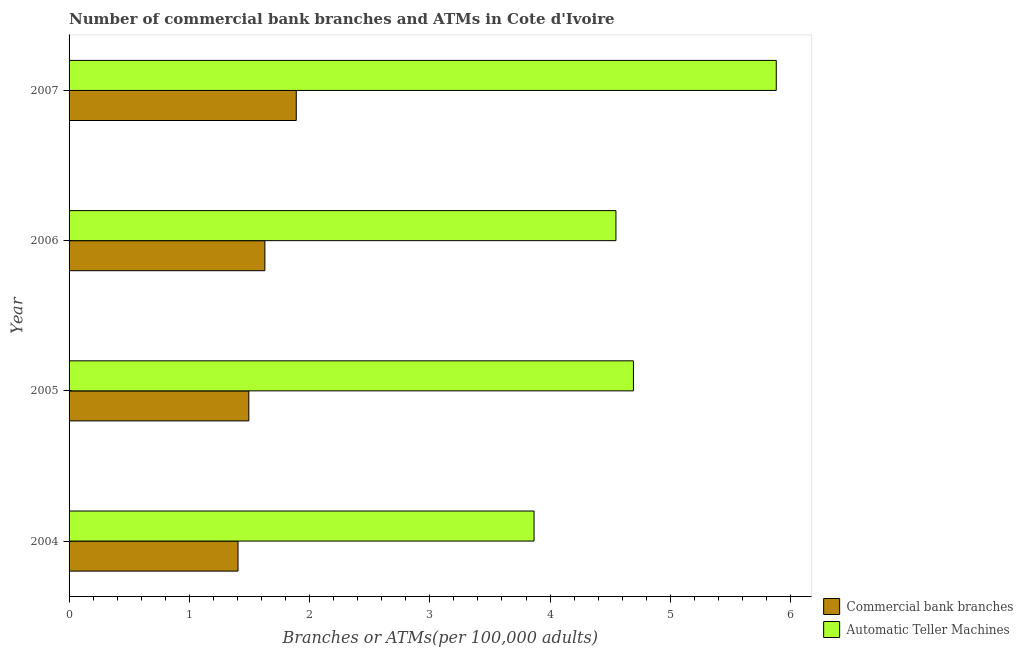How many different coloured bars are there?
Your response must be concise. 2. How many groups of bars are there?
Provide a succinct answer. 4. Are the number of bars per tick equal to the number of legend labels?
Your answer should be compact. Yes. How many bars are there on the 3rd tick from the bottom?
Your response must be concise. 2. What is the label of the 4th group of bars from the top?
Make the answer very short. 2004. In how many cases, is the number of bars for a given year not equal to the number of legend labels?
Offer a very short reply. 0. What is the number of atms in 2005?
Offer a terse response. 4.69. Across all years, what is the maximum number of commercal bank branches?
Your response must be concise. 1.89. Across all years, what is the minimum number of commercal bank branches?
Offer a terse response. 1.41. In which year was the number of commercal bank branches maximum?
Your answer should be very brief. 2007. What is the total number of atms in the graph?
Provide a succinct answer. 18.99. What is the difference between the number of atms in 2004 and that in 2006?
Give a very brief answer. -0.68. What is the difference between the number of commercal bank branches in 2005 and the number of atms in 2007?
Provide a succinct answer. -4.39. What is the average number of atms per year?
Provide a short and direct response. 4.75. In the year 2007, what is the difference between the number of commercal bank branches and number of atms?
Provide a short and direct response. -3.99. What is the ratio of the number of atms in 2005 to that in 2006?
Keep it short and to the point. 1.03. Is the number of commercal bank branches in 2006 less than that in 2007?
Ensure brevity in your answer.  Yes. Is the difference between the number of atms in 2004 and 2006 greater than the difference between the number of commercal bank branches in 2004 and 2006?
Provide a succinct answer. No. What is the difference between the highest and the second highest number of commercal bank branches?
Your answer should be compact. 0.26. What is the difference between the highest and the lowest number of commercal bank branches?
Make the answer very short. 0.48. In how many years, is the number of atms greater than the average number of atms taken over all years?
Make the answer very short. 1. What does the 1st bar from the top in 2007 represents?
Offer a very short reply. Automatic Teller Machines. What does the 2nd bar from the bottom in 2004 represents?
Provide a short and direct response. Automatic Teller Machines. Are all the bars in the graph horizontal?
Offer a very short reply. Yes. How many years are there in the graph?
Provide a succinct answer. 4. What is the difference between two consecutive major ticks on the X-axis?
Your response must be concise. 1. Are the values on the major ticks of X-axis written in scientific E-notation?
Provide a succinct answer. No. Does the graph contain grids?
Provide a succinct answer. No. Where does the legend appear in the graph?
Keep it short and to the point. Bottom right. What is the title of the graph?
Offer a very short reply. Number of commercial bank branches and ATMs in Cote d'Ivoire. Does "Constant 2005 US$" appear as one of the legend labels in the graph?
Keep it short and to the point. No. What is the label or title of the X-axis?
Give a very brief answer. Branches or ATMs(per 100,0 adults). What is the label or title of the Y-axis?
Ensure brevity in your answer.  Year. What is the Branches or ATMs(per 100,000 adults) in Commercial bank branches in 2004?
Your answer should be very brief. 1.41. What is the Branches or ATMs(per 100,000 adults) in Automatic Teller Machines in 2004?
Give a very brief answer. 3.87. What is the Branches or ATMs(per 100,000 adults) of Commercial bank branches in 2005?
Provide a short and direct response. 1.5. What is the Branches or ATMs(per 100,000 adults) in Automatic Teller Machines in 2005?
Ensure brevity in your answer.  4.69. What is the Branches or ATMs(per 100,000 adults) of Commercial bank branches in 2006?
Make the answer very short. 1.63. What is the Branches or ATMs(per 100,000 adults) in Automatic Teller Machines in 2006?
Make the answer very short. 4.55. What is the Branches or ATMs(per 100,000 adults) of Commercial bank branches in 2007?
Ensure brevity in your answer.  1.89. What is the Branches or ATMs(per 100,000 adults) of Automatic Teller Machines in 2007?
Make the answer very short. 5.88. Across all years, what is the maximum Branches or ATMs(per 100,000 adults) of Commercial bank branches?
Give a very brief answer. 1.89. Across all years, what is the maximum Branches or ATMs(per 100,000 adults) of Automatic Teller Machines?
Keep it short and to the point. 5.88. Across all years, what is the minimum Branches or ATMs(per 100,000 adults) in Commercial bank branches?
Your response must be concise. 1.41. Across all years, what is the minimum Branches or ATMs(per 100,000 adults) of Automatic Teller Machines?
Offer a terse response. 3.87. What is the total Branches or ATMs(per 100,000 adults) of Commercial bank branches in the graph?
Your answer should be very brief. 6.42. What is the total Branches or ATMs(per 100,000 adults) in Automatic Teller Machines in the graph?
Provide a succinct answer. 18.99. What is the difference between the Branches or ATMs(per 100,000 adults) of Commercial bank branches in 2004 and that in 2005?
Keep it short and to the point. -0.09. What is the difference between the Branches or ATMs(per 100,000 adults) of Automatic Teller Machines in 2004 and that in 2005?
Offer a very short reply. -0.83. What is the difference between the Branches or ATMs(per 100,000 adults) of Commercial bank branches in 2004 and that in 2006?
Your response must be concise. -0.22. What is the difference between the Branches or ATMs(per 100,000 adults) in Automatic Teller Machines in 2004 and that in 2006?
Give a very brief answer. -0.68. What is the difference between the Branches or ATMs(per 100,000 adults) of Commercial bank branches in 2004 and that in 2007?
Your answer should be very brief. -0.48. What is the difference between the Branches or ATMs(per 100,000 adults) in Automatic Teller Machines in 2004 and that in 2007?
Give a very brief answer. -2.01. What is the difference between the Branches or ATMs(per 100,000 adults) in Commercial bank branches in 2005 and that in 2006?
Make the answer very short. -0.13. What is the difference between the Branches or ATMs(per 100,000 adults) in Automatic Teller Machines in 2005 and that in 2006?
Offer a very short reply. 0.15. What is the difference between the Branches or ATMs(per 100,000 adults) in Commercial bank branches in 2005 and that in 2007?
Ensure brevity in your answer.  -0.39. What is the difference between the Branches or ATMs(per 100,000 adults) in Automatic Teller Machines in 2005 and that in 2007?
Provide a succinct answer. -1.19. What is the difference between the Branches or ATMs(per 100,000 adults) of Commercial bank branches in 2006 and that in 2007?
Provide a succinct answer. -0.26. What is the difference between the Branches or ATMs(per 100,000 adults) of Automatic Teller Machines in 2006 and that in 2007?
Ensure brevity in your answer.  -1.33. What is the difference between the Branches or ATMs(per 100,000 adults) in Commercial bank branches in 2004 and the Branches or ATMs(per 100,000 adults) in Automatic Teller Machines in 2005?
Provide a succinct answer. -3.29. What is the difference between the Branches or ATMs(per 100,000 adults) in Commercial bank branches in 2004 and the Branches or ATMs(per 100,000 adults) in Automatic Teller Machines in 2006?
Give a very brief answer. -3.14. What is the difference between the Branches or ATMs(per 100,000 adults) in Commercial bank branches in 2004 and the Branches or ATMs(per 100,000 adults) in Automatic Teller Machines in 2007?
Your answer should be very brief. -4.48. What is the difference between the Branches or ATMs(per 100,000 adults) in Commercial bank branches in 2005 and the Branches or ATMs(per 100,000 adults) in Automatic Teller Machines in 2006?
Your answer should be compact. -3.05. What is the difference between the Branches or ATMs(per 100,000 adults) of Commercial bank branches in 2005 and the Branches or ATMs(per 100,000 adults) of Automatic Teller Machines in 2007?
Your answer should be very brief. -4.39. What is the difference between the Branches or ATMs(per 100,000 adults) in Commercial bank branches in 2006 and the Branches or ATMs(per 100,000 adults) in Automatic Teller Machines in 2007?
Provide a succinct answer. -4.25. What is the average Branches or ATMs(per 100,000 adults) of Commercial bank branches per year?
Make the answer very short. 1.6. What is the average Branches or ATMs(per 100,000 adults) in Automatic Teller Machines per year?
Offer a terse response. 4.75. In the year 2004, what is the difference between the Branches or ATMs(per 100,000 adults) of Commercial bank branches and Branches or ATMs(per 100,000 adults) of Automatic Teller Machines?
Ensure brevity in your answer.  -2.46. In the year 2005, what is the difference between the Branches or ATMs(per 100,000 adults) of Commercial bank branches and Branches or ATMs(per 100,000 adults) of Automatic Teller Machines?
Give a very brief answer. -3.2. In the year 2006, what is the difference between the Branches or ATMs(per 100,000 adults) of Commercial bank branches and Branches or ATMs(per 100,000 adults) of Automatic Teller Machines?
Keep it short and to the point. -2.92. In the year 2007, what is the difference between the Branches or ATMs(per 100,000 adults) of Commercial bank branches and Branches or ATMs(per 100,000 adults) of Automatic Teller Machines?
Your answer should be very brief. -3.99. What is the ratio of the Branches or ATMs(per 100,000 adults) of Commercial bank branches in 2004 to that in 2005?
Your answer should be very brief. 0.94. What is the ratio of the Branches or ATMs(per 100,000 adults) in Automatic Teller Machines in 2004 to that in 2005?
Make the answer very short. 0.82. What is the ratio of the Branches or ATMs(per 100,000 adults) in Commercial bank branches in 2004 to that in 2006?
Your answer should be very brief. 0.86. What is the ratio of the Branches or ATMs(per 100,000 adults) in Automatic Teller Machines in 2004 to that in 2006?
Provide a short and direct response. 0.85. What is the ratio of the Branches or ATMs(per 100,000 adults) in Commercial bank branches in 2004 to that in 2007?
Make the answer very short. 0.74. What is the ratio of the Branches or ATMs(per 100,000 adults) of Automatic Teller Machines in 2004 to that in 2007?
Your answer should be compact. 0.66. What is the ratio of the Branches or ATMs(per 100,000 adults) of Commercial bank branches in 2005 to that in 2006?
Offer a terse response. 0.92. What is the ratio of the Branches or ATMs(per 100,000 adults) of Automatic Teller Machines in 2005 to that in 2006?
Give a very brief answer. 1.03. What is the ratio of the Branches or ATMs(per 100,000 adults) of Commercial bank branches in 2005 to that in 2007?
Make the answer very short. 0.79. What is the ratio of the Branches or ATMs(per 100,000 adults) of Automatic Teller Machines in 2005 to that in 2007?
Your answer should be very brief. 0.8. What is the ratio of the Branches or ATMs(per 100,000 adults) of Commercial bank branches in 2006 to that in 2007?
Offer a terse response. 0.86. What is the ratio of the Branches or ATMs(per 100,000 adults) in Automatic Teller Machines in 2006 to that in 2007?
Offer a very short reply. 0.77. What is the difference between the highest and the second highest Branches or ATMs(per 100,000 adults) of Commercial bank branches?
Offer a very short reply. 0.26. What is the difference between the highest and the second highest Branches or ATMs(per 100,000 adults) of Automatic Teller Machines?
Your answer should be very brief. 1.19. What is the difference between the highest and the lowest Branches or ATMs(per 100,000 adults) in Commercial bank branches?
Offer a very short reply. 0.48. What is the difference between the highest and the lowest Branches or ATMs(per 100,000 adults) of Automatic Teller Machines?
Keep it short and to the point. 2.01. 